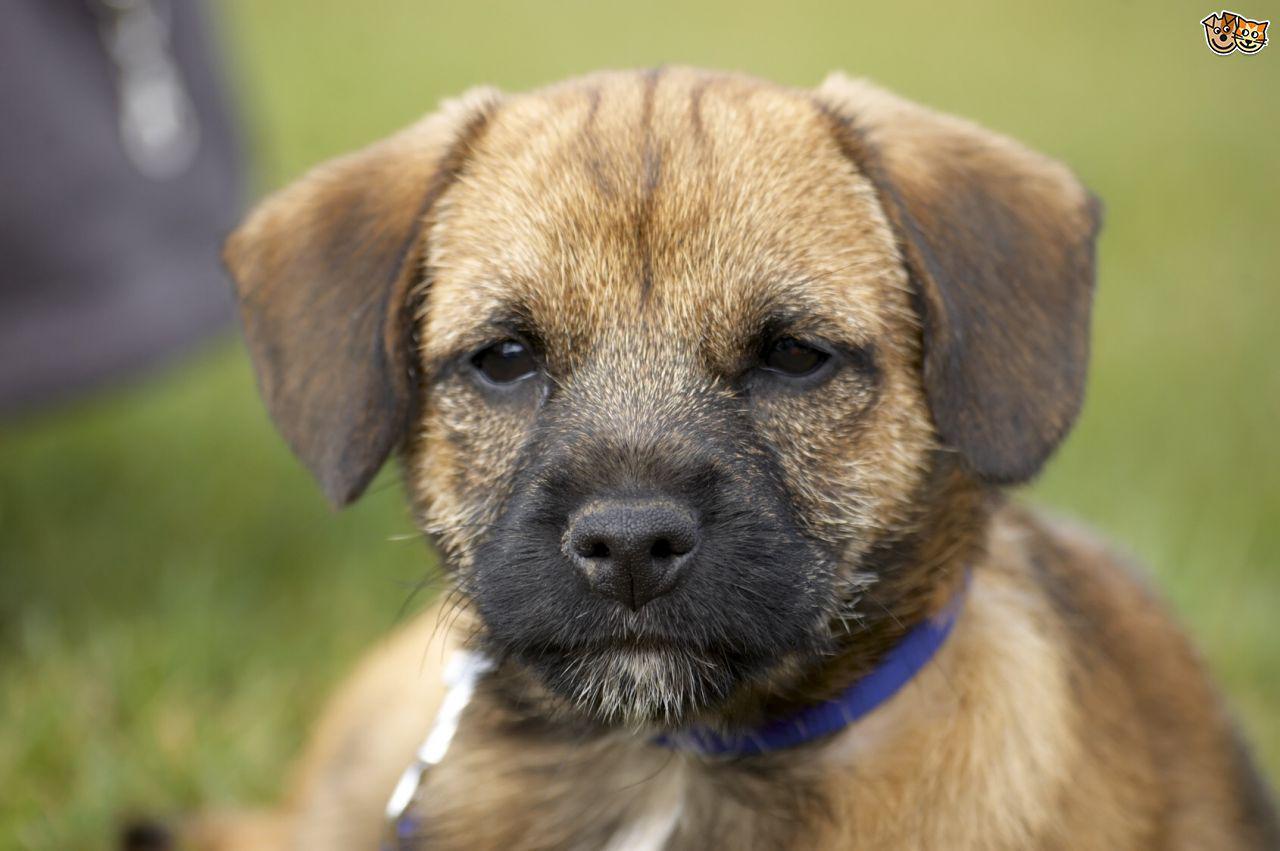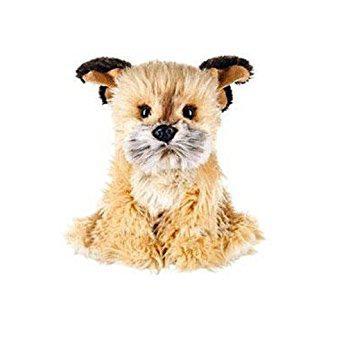The first image is the image on the left, the second image is the image on the right. Assess this claim about the two images: "On the right, the dog's body is turned to the left.". Correct or not? Answer yes or no. No. The first image is the image on the left, the second image is the image on the right. Evaluate the accuracy of this statement regarding the images: "there is no visible grass". Is it true? Answer yes or no. No. 